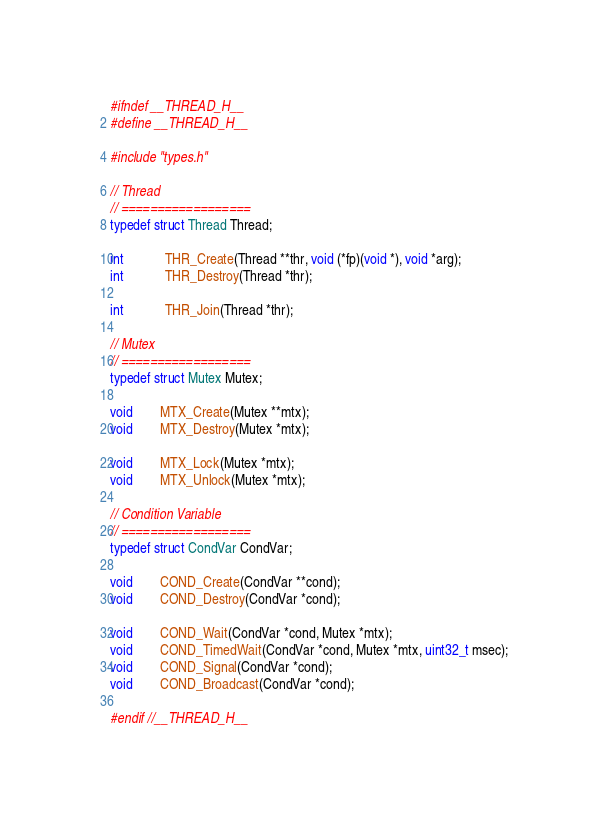<code> <loc_0><loc_0><loc_500><loc_500><_C_>#ifndef __THREAD_H__
#define __THREAD_H__

#include "types.h"

// Thread
// ==================
typedef struct Thread Thread;

int			THR_Create(Thread **thr, void (*fp)(void *), void *arg);
int			THR_Destroy(Thread *thr);

int			THR_Join(Thread *thr);

// Mutex
// ==================
typedef struct Mutex Mutex;

void		MTX_Create(Mutex **mtx);
void		MTX_Destroy(Mutex *mtx);

void		MTX_Lock(Mutex *mtx);
void		MTX_Unlock(Mutex *mtx);

// Condition Variable
// ==================
typedef struct CondVar CondVar;

void		COND_Create(CondVar **cond);
void		COND_Destroy(CondVar *cond);

void		COND_Wait(CondVar *cond, Mutex *mtx);
void		COND_TimedWait(CondVar *cond, Mutex *mtx, uint32_t msec);
void		COND_Signal(CondVar *cond);
void		COND_Broadcast(CondVar *cond);

#endif //__THREAD_H__</code> 